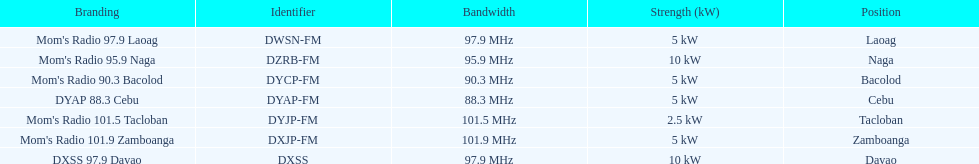How many kw was the radio in davao? 10 kW. 